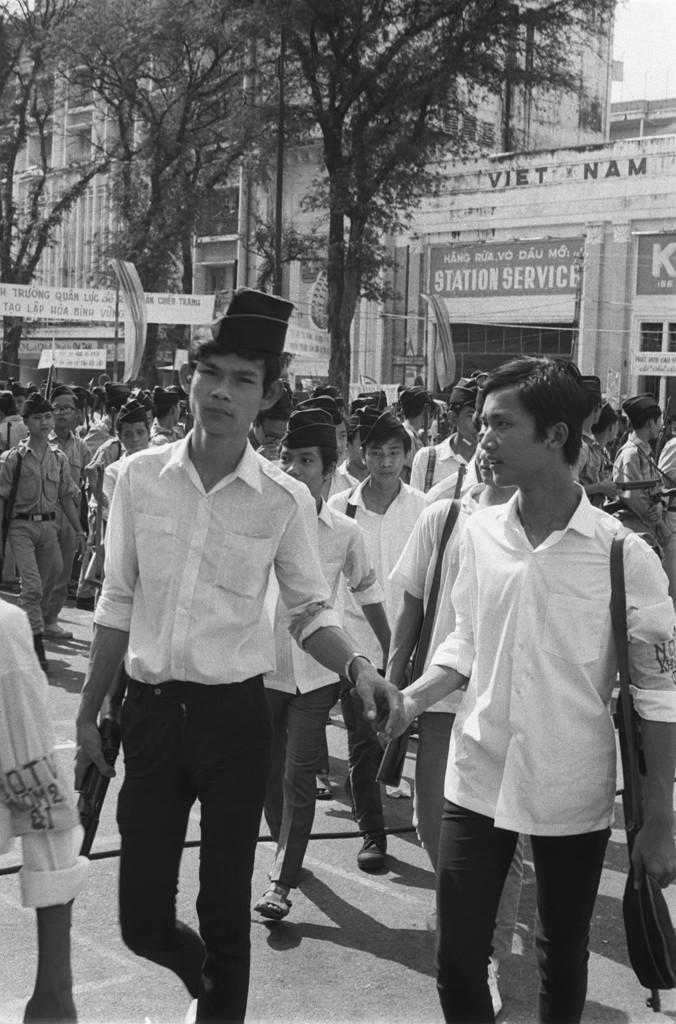What is happening on the road in the image? There is a group of people on the road. What can be seen in the background of the image? In the background, there are banners, posters, buildings, trees, and some unspecified objects. Can you describe the banners in the background? Unfortunately, the facts provided do not give specific details about the banners. How many different types of objects are visible in the background? There are five different types of objects visible in the background: banners, posters, buildings, trees, and unspecified objects. What type of knowledge is being shared by the ants in the image? There are no ants present in the image, so it is not possible to determine what type of knowledge they might be sharing. 